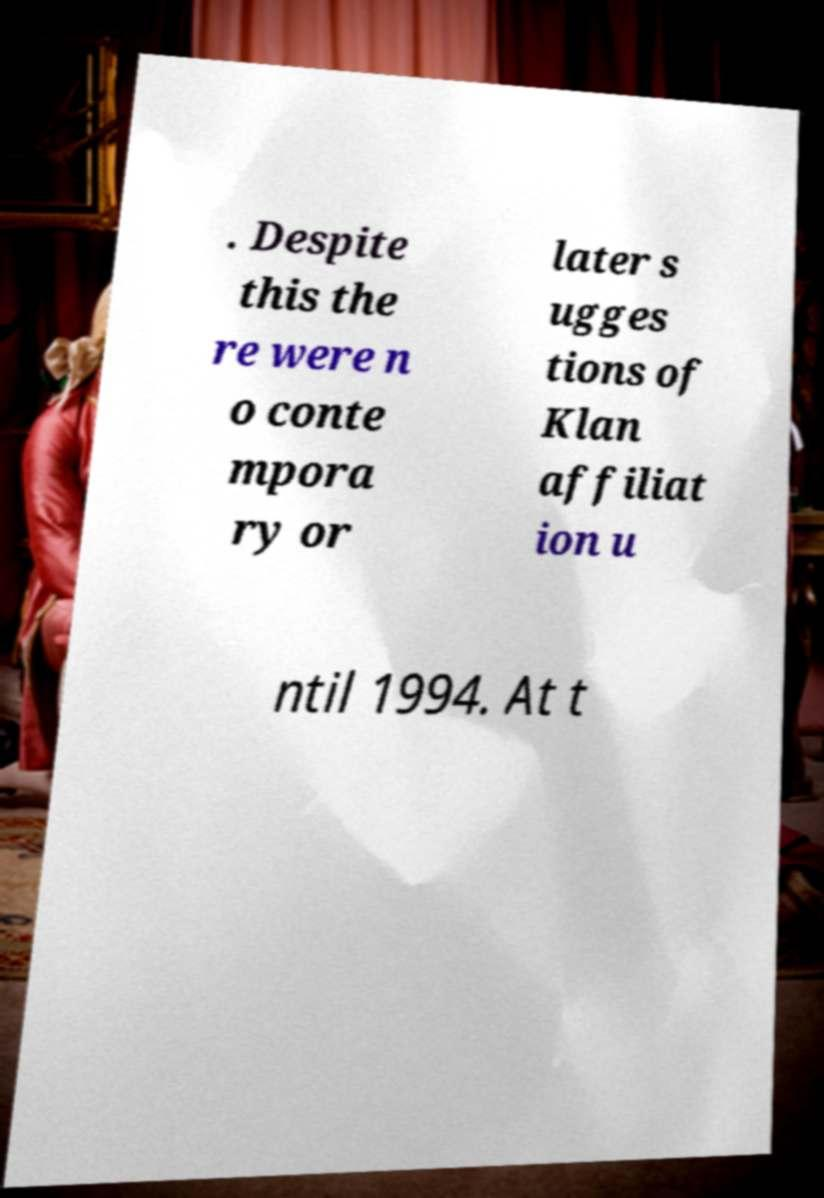There's text embedded in this image that I need extracted. Can you transcribe it verbatim? . Despite this the re were n o conte mpora ry or later s ugges tions of Klan affiliat ion u ntil 1994. At t 